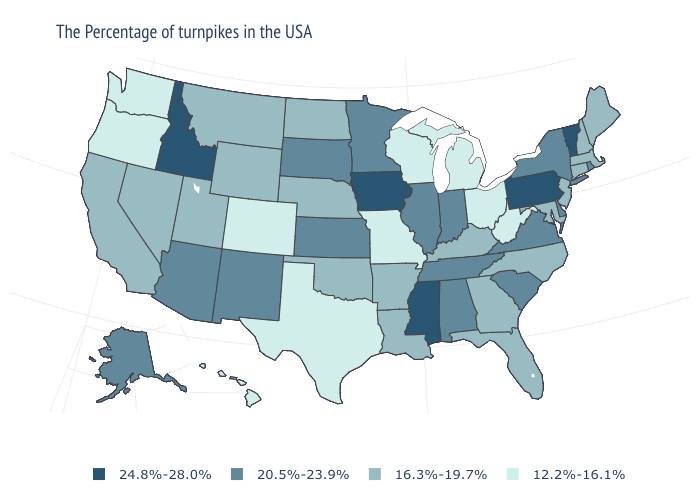Name the states that have a value in the range 12.2%-16.1%?
Keep it brief. West Virginia, Ohio, Michigan, Wisconsin, Missouri, Texas, Colorado, Washington, Oregon, Hawaii. What is the value of North Dakota?
Write a very short answer. 16.3%-19.7%. Does Massachusetts have a lower value than Nebraska?
Quick response, please. No. Which states have the highest value in the USA?
Be succinct. Vermont, Pennsylvania, Mississippi, Iowa, Idaho. What is the lowest value in the Northeast?
Keep it brief. 16.3%-19.7%. What is the highest value in states that border Massachusetts?
Concise answer only. 24.8%-28.0%. What is the value of Idaho?
Write a very short answer. 24.8%-28.0%. Does Virginia have a higher value than Iowa?
Give a very brief answer. No. Which states hav the highest value in the South?
Write a very short answer. Mississippi. Is the legend a continuous bar?
Keep it brief. No. Among the states that border Colorado , which have the highest value?
Write a very short answer. Kansas, New Mexico, Arizona. What is the lowest value in states that border New Hampshire?
Concise answer only. 16.3%-19.7%. What is the highest value in the USA?
Keep it brief. 24.8%-28.0%. What is the value of South Carolina?
Concise answer only. 20.5%-23.9%. Among the states that border Ohio , which have the lowest value?
Be succinct. West Virginia, Michigan. 